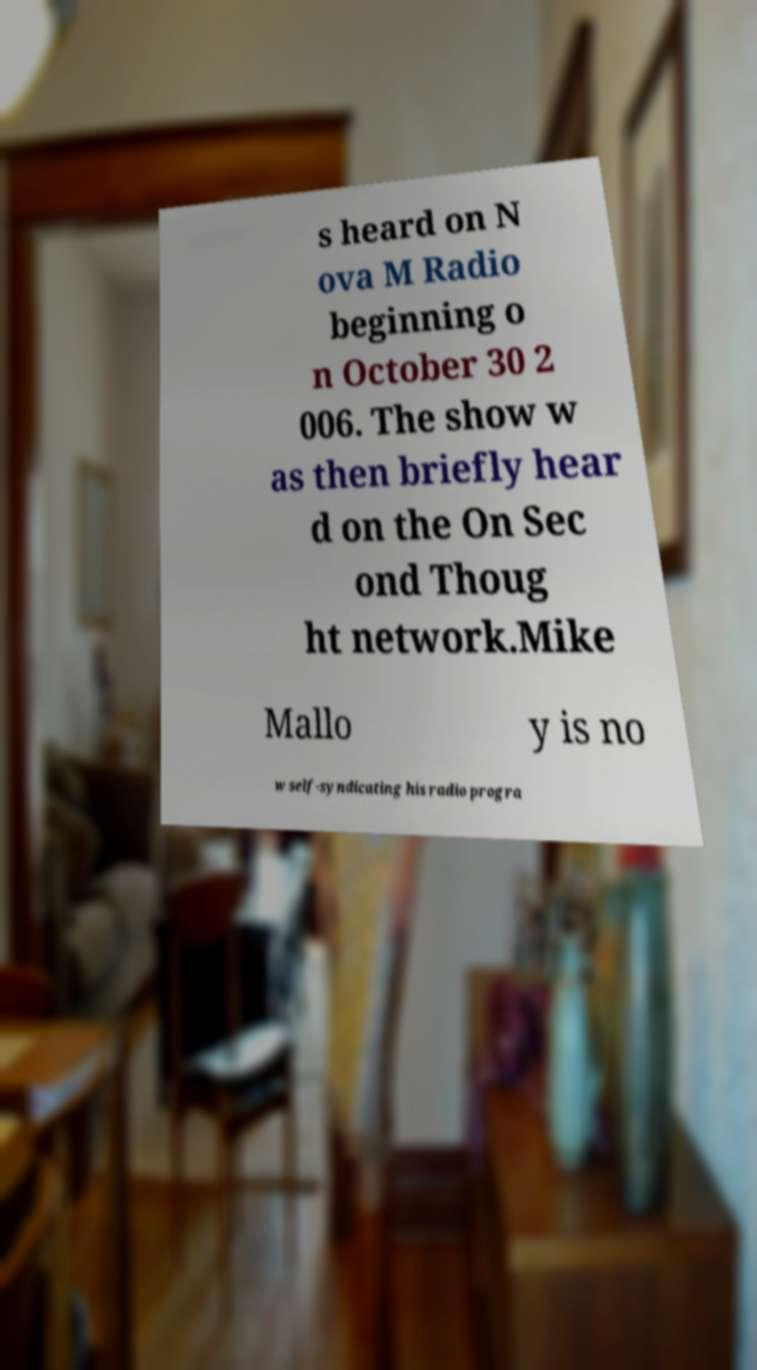Could you extract and type out the text from this image? s heard on N ova M Radio beginning o n October 30 2 006. The show w as then briefly hear d on the On Sec ond Thoug ht network.Mike Mallo y is no w self-syndicating his radio progra 